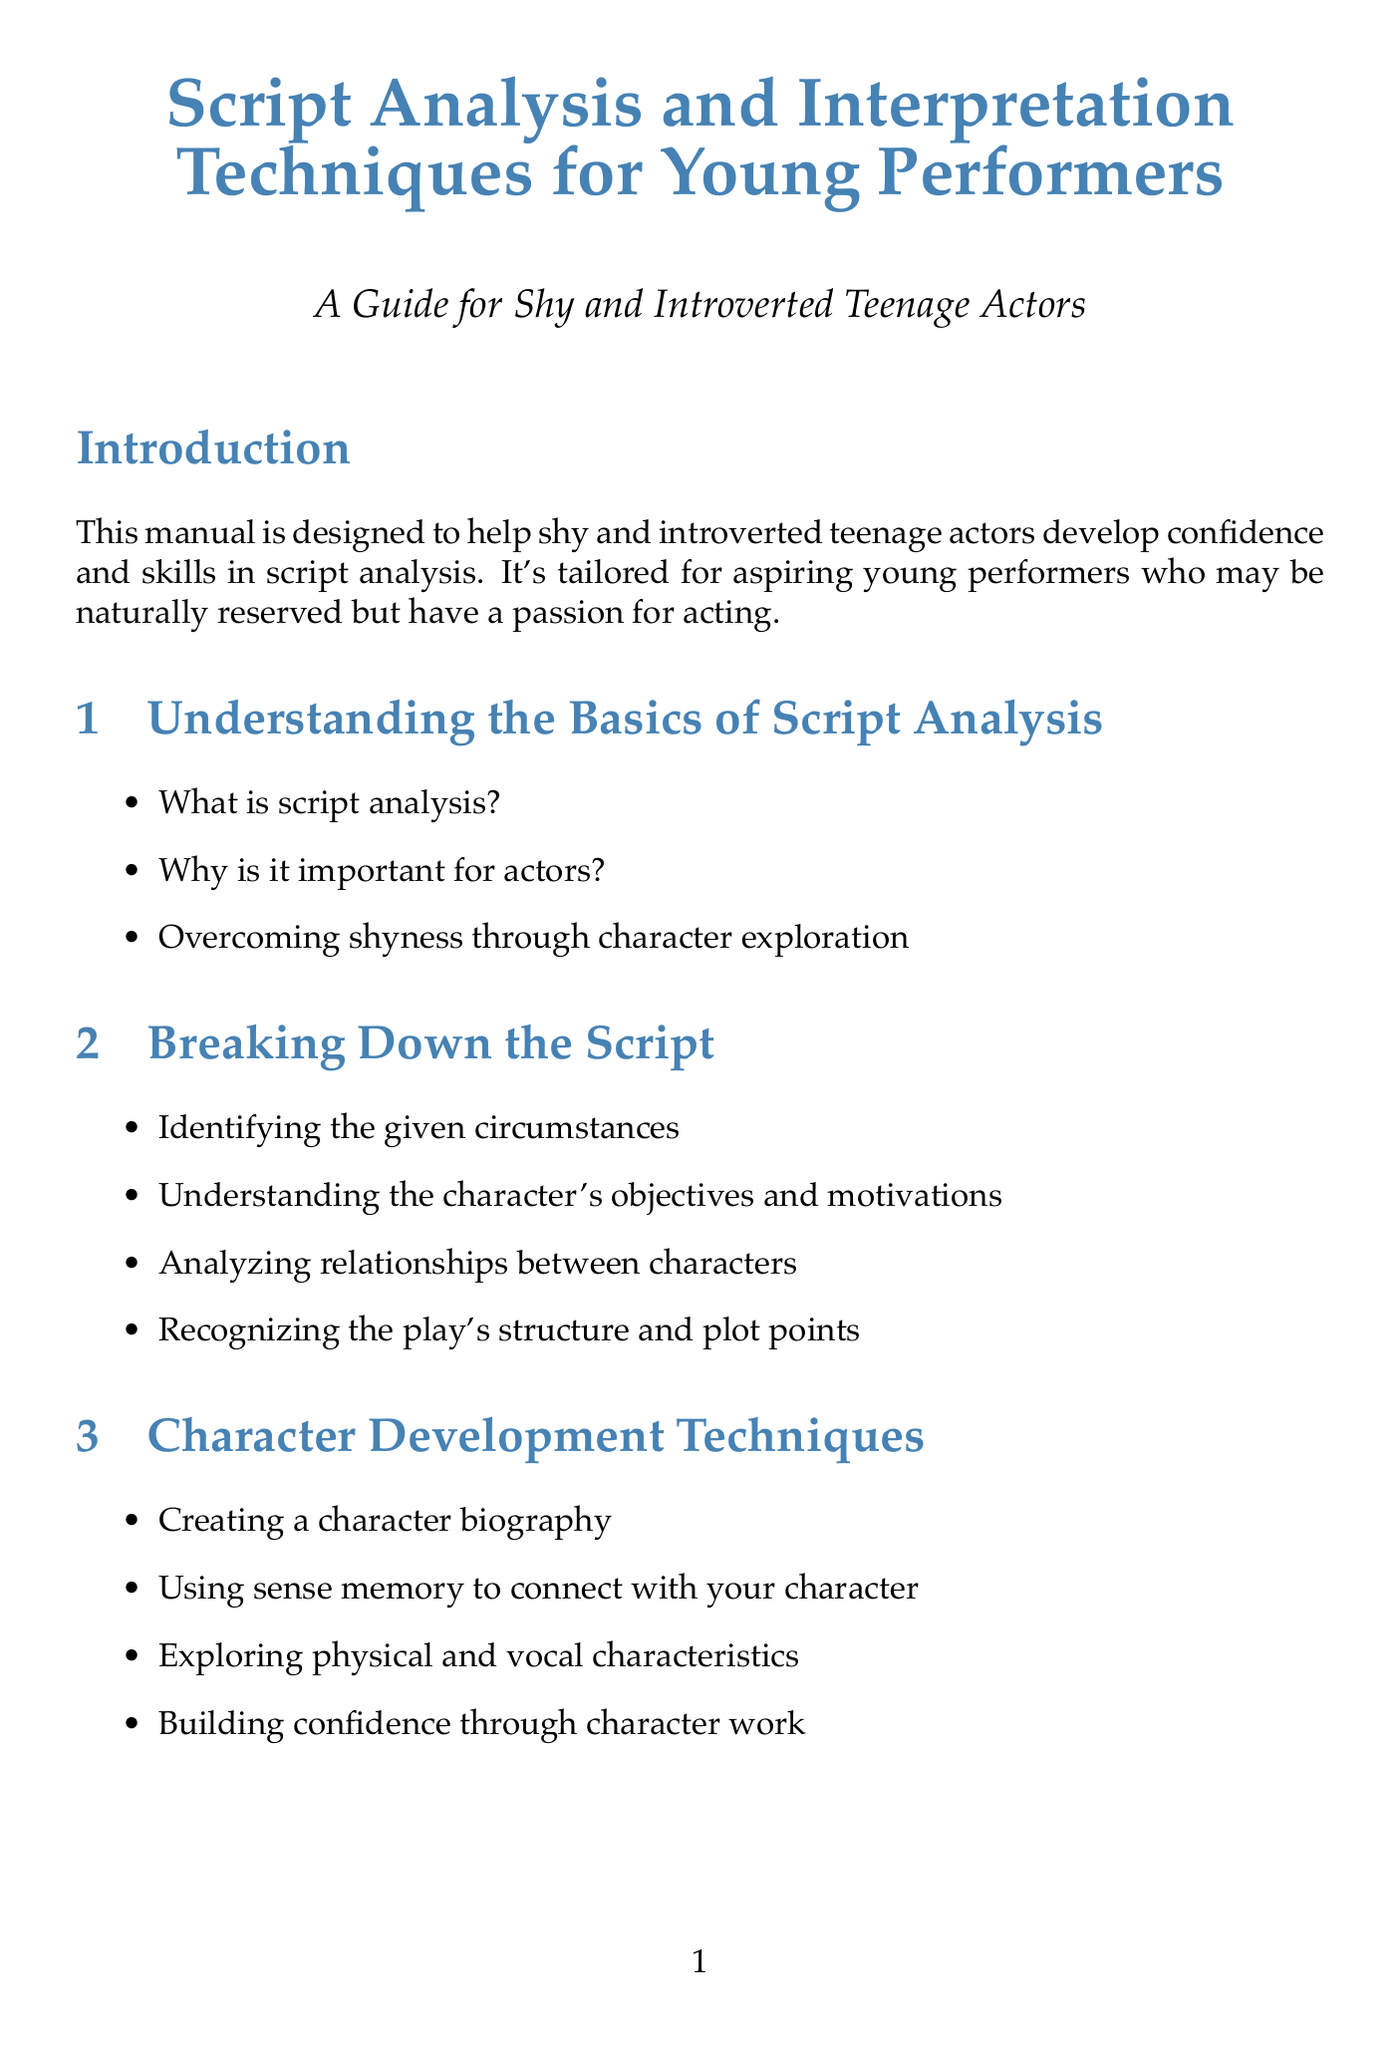What is the title of the manual? The title of the manual is stated at the beginning of the document.
Answer: Script Analysis and Interpretation Techniques for Young Performers Who is the target audience? The target audience is specified in the introduction section of the document.
Answer: Aspiring young actors, particularly those who are naturally reserved What chapter covers character development techniques? The chapter title can be found in the table of contents of the document.
Answer: Character Development Techniques Which book is recommended for actors? The recommended books are listed under the resources section.
Answer: An Actor Prepares by Constantin Stanislavski How many sections are there in the chapter on Breaking Down the Script? The number of sections can be counted in the chapter listed in the document.
Answer: Four What is one technique mentioned for managing stage fright? The technique is mentioned in the emotional preparation chapter of the document.
Answer: Building emotional resilience as an introverted actor What is the first exercise listed in the Practice Exercises section? The exercises are outlined in the practice exercises and worksheets section of the document.
Answer: Script analysis worksheet for 'Romeo and Juliet' by William Shakespeare What is a key takeaway from the conclusion? The key takeaways are summarized in the conclusion section of the document.
Answer: Script analysis is a fundamental skill for all actors 